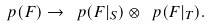Convert formula to latex. <formula><loc_0><loc_0><loc_500><loc_500>\ p ( F ) \rightarrow \ p ( F | _ { S } ) \otimes \ p ( F | _ { T } ) .</formula> 